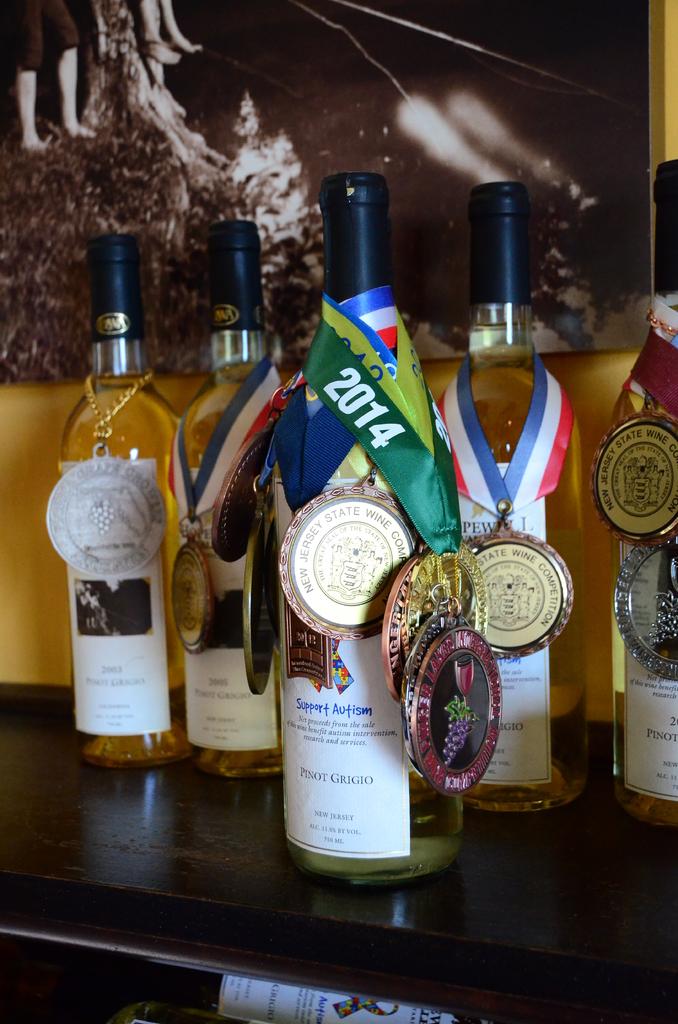What year is the medal from?
Offer a terse response. 2014. What is brand of front, center bottle?
Make the answer very short. Support autism. 